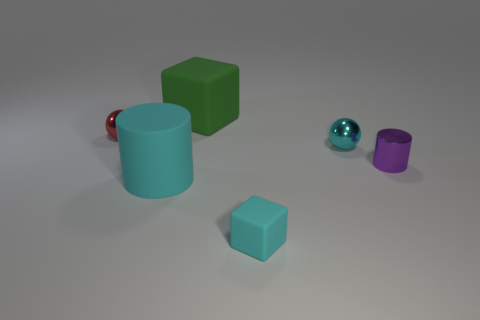The other rubber thing that is the same size as the purple object is what color?
Offer a very short reply. Cyan. What size is the other object that is the same shape as the cyan metallic thing?
Keep it short and to the point. Small. There is a tiny cyan object in front of the large cyan rubber cylinder; what shape is it?
Provide a short and direct response. Cube. Does the tiny matte thing have the same shape as the tiny cyan object behind the tiny purple cylinder?
Keep it short and to the point. No. Are there the same number of shiny cylinders in front of the big green thing and purple objects behind the tiny red ball?
Offer a terse response. No. There is a matte thing that is the same color as the big rubber cylinder; what is its shape?
Make the answer very short. Cube. There is a cylinder in front of the tiny shiny cylinder; is it the same color as the shiny thing that is on the left side of the tiny cyan rubber thing?
Offer a very short reply. No. Is the number of big rubber cylinders that are behind the red shiny ball greater than the number of big red metallic blocks?
Offer a very short reply. No. What is the material of the green cube?
Your answer should be compact. Rubber. There is a cyan thing that is the same material as the large cylinder; what is its shape?
Ensure brevity in your answer.  Cube. 